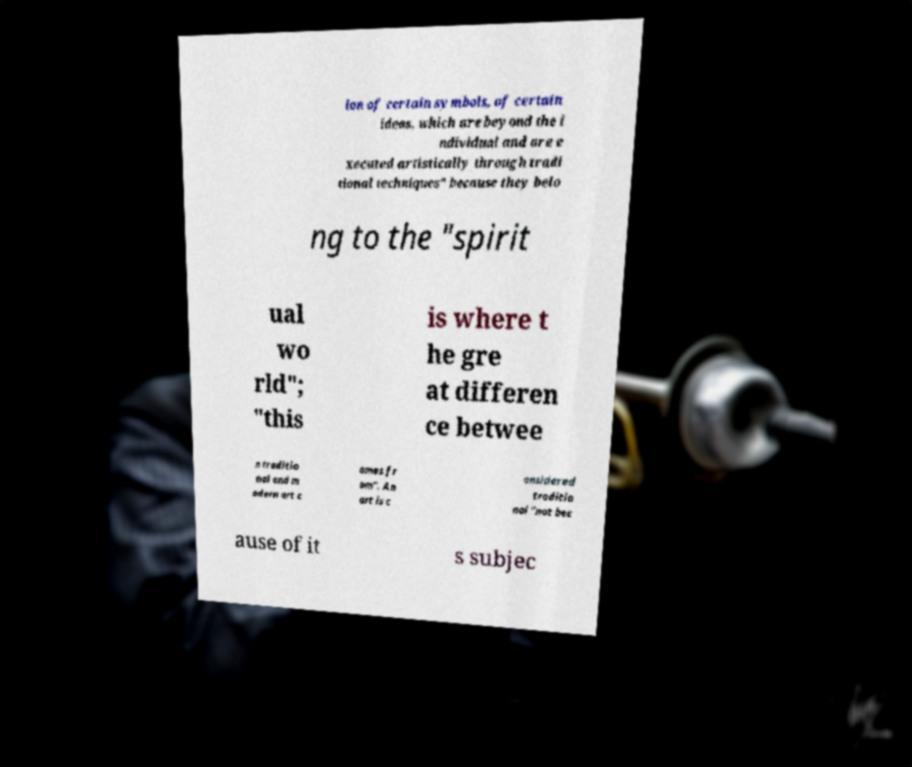Could you assist in decoding the text presented in this image and type it out clearly? ion of certain symbols, of certain ideas, which are beyond the i ndividual and are e xecuted artistically through tradi tional techniques" because they belo ng to the "spirit ual wo rld"; "this is where t he gre at differen ce betwee n traditio nal and m odern art c omes fr om". An art is c onsidered traditio nal "not bec ause of it s subjec 